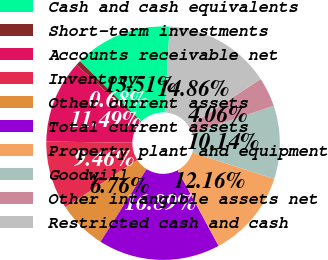Convert chart. <chart><loc_0><loc_0><loc_500><loc_500><pie_chart><fcel>Cash and cash equivalents<fcel>Short-term investments<fcel>Accounts receivable net<fcel>Inventory<fcel>Other current assets<fcel>Total current assets<fcel>Property plant and equipment<fcel>Goodwill<fcel>Other intangible assets net<fcel>Restricted cash and cash<nl><fcel>13.51%<fcel>0.68%<fcel>11.49%<fcel>9.46%<fcel>6.76%<fcel>16.89%<fcel>12.16%<fcel>10.14%<fcel>4.06%<fcel>14.86%<nl></chart> 